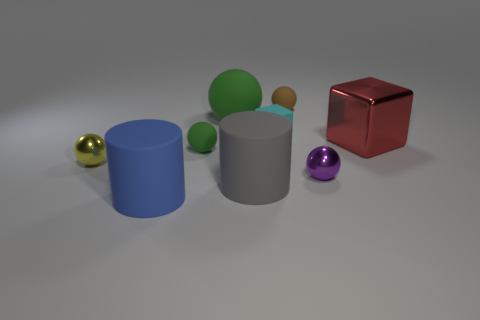Can you explain the different textures visible in the objects? Certainly! The image shows objects with varying textures. The red cube has a shiny, almost reflective surface, suggesting a metallic texture. The gray and blue cylinders appear to have a matte finish, giving them a soft and non-reflective appearance, which is often associated with rubber or plastic materials. The spheres also have different textures; the small purple and golden spheres are glossy, likely indicative of a polished metallic finish, while the green spheres have a less reflective, matte finish. 